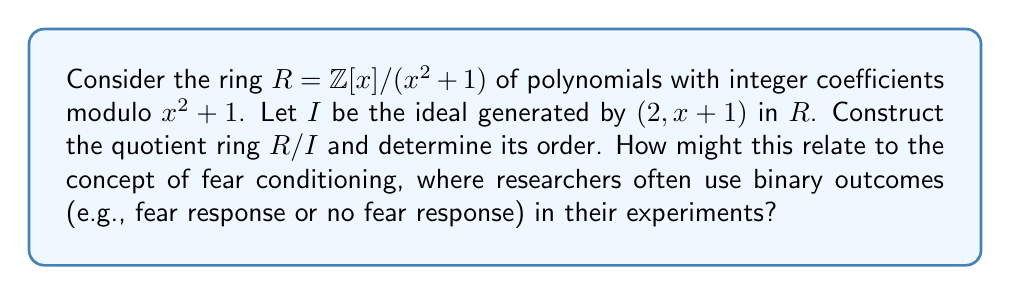Teach me how to tackle this problem. To construct the quotient ring $R/I$ and determine its order, we'll follow these steps:

1) First, let's understand what $R$ is:
   $R = \mathbb{Z}[x]/(x^2 + 1)$ means that in $R$, $x^2 = -1$.

2) The ideal $I$ is generated by $(2, x+1)$. This means that in $R/I$:
   $2 \equiv 0 \pmod{I}$ and $x+1 \equiv 0 \pmod{I}$

3) From $x+1 \equiv 0 \pmod{I}$, we can deduce that $x \equiv -1 \pmod{I}$

4) Now, let's consider an arbitrary element of $R$:
   $ax + b$, where $a, b \in \mathbb{Z}$

5) In $R/I$, this becomes:
   $ax + b \equiv a(-1) + b \equiv -a + b \pmod{I}$

6) Since $2 \equiv 0 \pmod{I}$, we only need to consider $a$ and $b$ modulo 2.

7) This means that every element in $R/I$ can be represented uniquely as either $0$ or $1$.

8) Therefore, $R/I$ is isomorphic to $\mathbb{Z}/2\mathbb{Z}$, the ring of integers modulo 2.

9) The order of $R/I$ is thus 2.

This binary structure of the quotient ring relates to fear conditioning experiments, where researchers often use binary outcomes (fear response or no fear response). Just as the quotient ring reduces complex polynomial expressions to a simple binary system, fear conditioning experiments often reduce complex fear responses to binary data points, simplifying analysis while still capturing essential information about fear manipulation.
Answer: The quotient ring $R/I$ is isomorphic to $\mathbb{Z}/2\mathbb{Z}$, and its order is 2. 